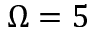Convert formula to latex. <formula><loc_0><loc_0><loc_500><loc_500>\Omega = 5</formula> 